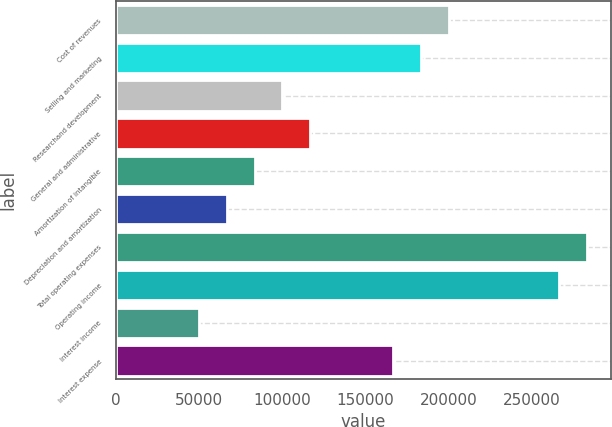Convert chart to OTSL. <chart><loc_0><loc_0><loc_500><loc_500><bar_chart><fcel>Cost of revenues<fcel>Selling and marketing<fcel>Researchand development<fcel>General and administrative<fcel>Amortization of intangible<fcel>Depreciation and amortization<fcel>Total operating expenses<fcel>Operating income<fcel>Interest income<fcel>Interest expense<nl><fcel>200160<fcel>183480<fcel>100080<fcel>116760<fcel>83400.4<fcel>66720.4<fcel>283560<fcel>266880<fcel>50040.5<fcel>166800<nl></chart> 